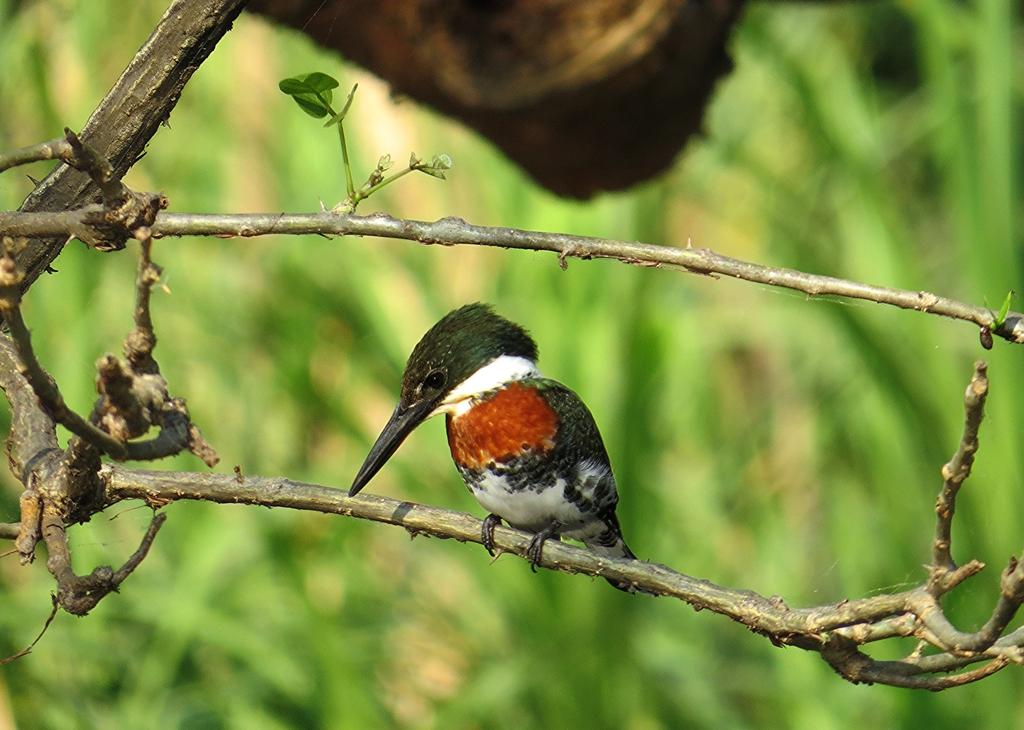What type of animal is in the image? There is a bird in the image. Where is the bird located? The bird is on a tree branch. Can you describe the background of the image? The background of the image is blurred. What type of hands can be seen holding the bird in the image? There are no hands visible in the image; the bird is on a tree branch. 